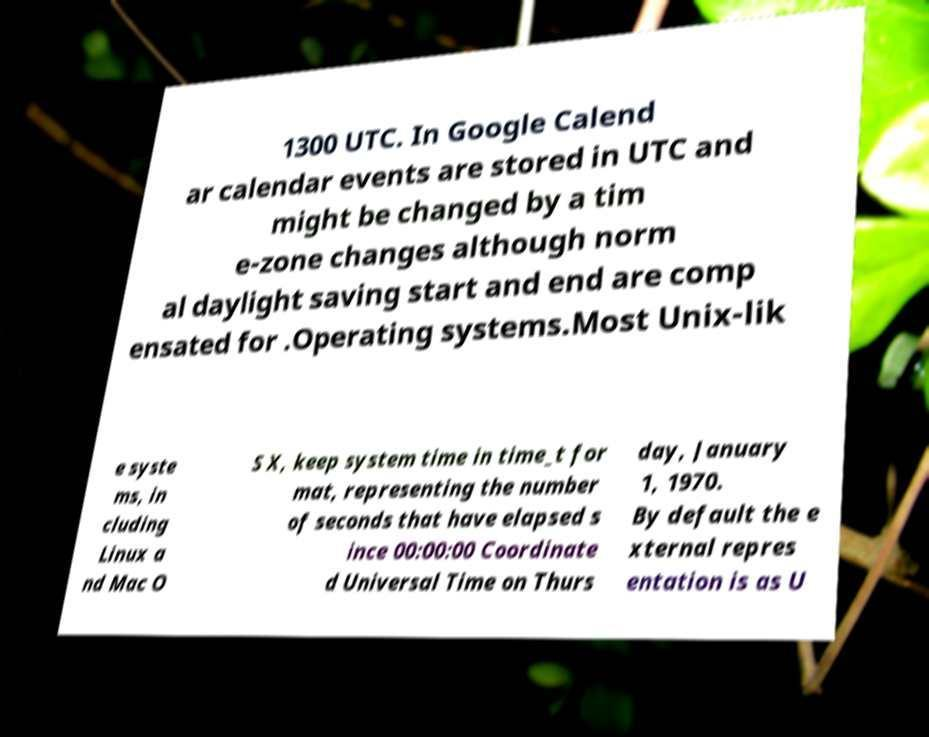What messages or text are displayed in this image? I need them in a readable, typed format. 1300 UTC. In Google Calend ar calendar events are stored in UTC and might be changed by a tim e-zone changes although norm al daylight saving start and end are comp ensated for .Operating systems.Most Unix-lik e syste ms, in cluding Linux a nd Mac O S X, keep system time in time_t for mat, representing the number of seconds that have elapsed s ince 00:00:00 Coordinate d Universal Time on Thurs day, January 1, 1970. By default the e xternal repres entation is as U 